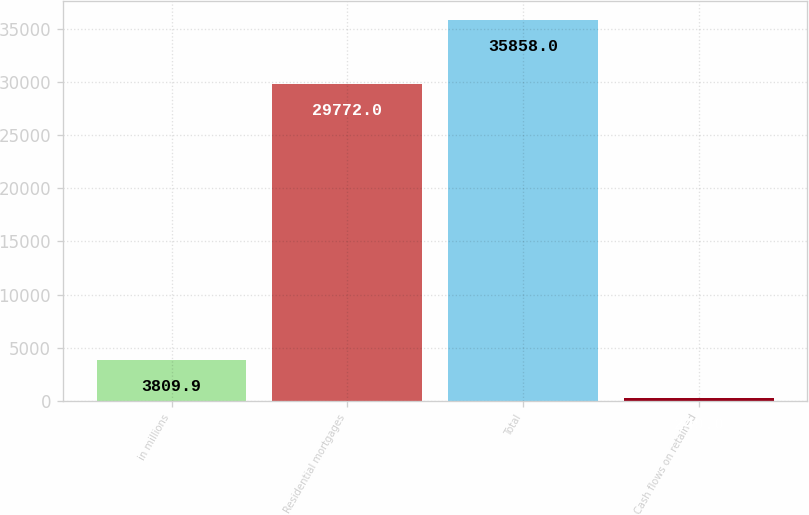Convert chart to OTSL. <chart><loc_0><loc_0><loc_500><loc_500><bar_chart><fcel>in millions<fcel>Residential mortgages<fcel>Total<fcel>Cash flows on retained<nl><fcel>3809.9<fcel>29772<fcel>35858<fcel>249<nl></chart> 